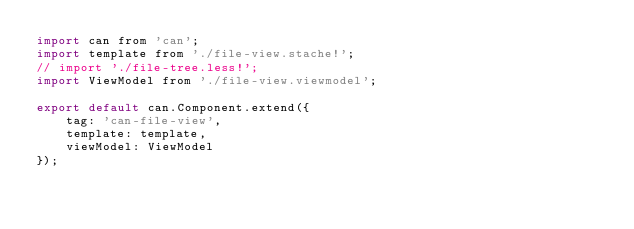<code> <loc_0><loc_0><loc_500><loc_500><_JavaScript_>import can from 'can';
import template from './file-view.stache!';
// import './file-tree.less!';
import ViewModel from './file-view.viewmodel';

export default can.Component.extend({
    tag: 'can-file-view',
    template: template,
    viewModel: ViewModel
});
</code> 